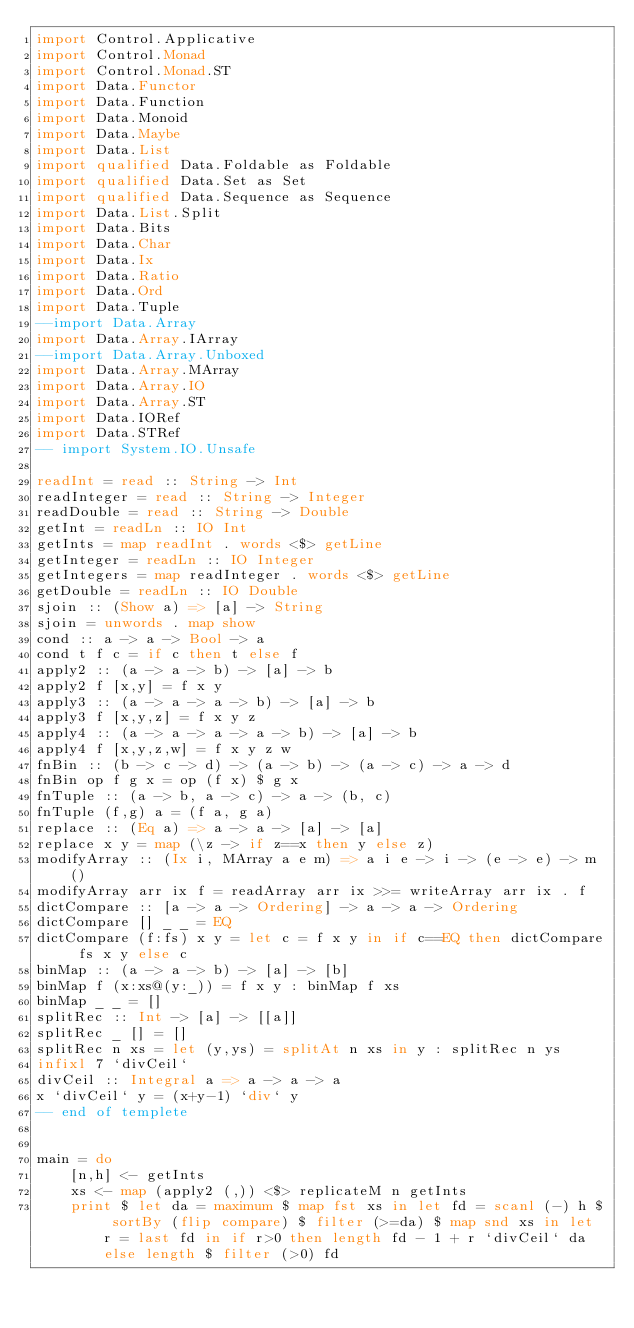<code> <loc_0><loc_0><loc_500><loc_500><_Haskell_>import Control.Applicative
import Control.Monad
import Control.Monad.ST
import Data.Functor
import Data.Function
import Data.Monoid
import Data.Maybe
import Data.List
import qualified Data.Foldable as Foldable
import qualified Data.Set as Set
import qualified Data.Sequence as Sequence
import Data.List.Split
import Data.Bits
import Data.Char
import Data.Ix
import Data.Ratio
import Data.Ord
import Data.Tuple
--import Data.Array
import Data.Array.IArray
--import Data.Array.Unboxed
import Data.Array.MArray
import Data.Array.IO
import Data.Array.ST
import Data.IORef
import Data.STRef
-- import System.IO.Unsafe
 
readInt = read :: String -> Int
readInteger = read :: String -> Integer
readDouble = read :: String -> Double
getInt = readLn :: IO Int
getInts = map readInt . words <$> getLine
getInteger = readLn :: IO Integer
getIntegers = map readInteger . words <$> getLine
getDouble = readLn :: IO Double
sjoin :: (Show a) => [a] -> String
sjoin = unwords . map show
cond :: a -> a -> Bool -> a
cond t f c = if c then t else f
apply2 :: (a -> a -> b) -> [a] -> b
apply2 f [x,y] = f x y
apply3 :: (a -> a -> a -> b) -> [a] -> b
apply3 f [x,y,z] = f x y z
apply4 :: (a -> a -> a -> a -> b) -> [a] -> b
apply4 f [x,y,z,w] = f x y z w
fnBin :: (b -> c -> d) -> (a -> b) -> (a -> c) -> a -> d
fnBin op f g x = op (f x) $ g x
fnTuple :: (a -> b, a -> c) -> a -> (b, c)
fnTuple (f,g) a = (f a, g a)
replace :: (Eq a) => a -> a -> [a] -> [a]
replace x y = map (\z -> if z==x then y else z)
modifyArray :: (Ix i, MArray a e m) => a i e -> i -> (e -> e) -> m ()
modifyArray arr ix f = readArray arr ix >>= writeArray arr ix . f
dictCompare :: [a -> a -> Ordering] -> a -> a -> Ordering
dictCompare [] _ _ = EQ
dictCompare (f:fs) x y = let c = f x y in if c==EQ then dictCompare fs x y else c
binMap :: (a -> a -> b) -> [a] -> [b]
binMap f (x:xs@(y:_)) = f x y : binMap f xs
binMap _ _ = []
splitRec :: Int -> [a] -> [[a]]
splitRec _ [] = []
splitRec n xs = let (y,ys) = splitAt n xs in y : splitRec n ys
infixl 7 `divCeil`
divCeil :: Integral a => a -> a -> a
x `divCeil` y = (x+y-1) `div` y
-- end of templete


main = do
    [n,h] <- getInts
    xs <- map (apply2 (,)) <$> replicateM n getInts
    print $ let da = maximum $ map fst xs in let fd = scanl (-) h $ sortBy (flip compare) $ filter (>=da) $ map snd xs in let r = last fd in if r>0 then length fd - 1 + r `divCeil` da else length $ filter (>0) fd
</code> 